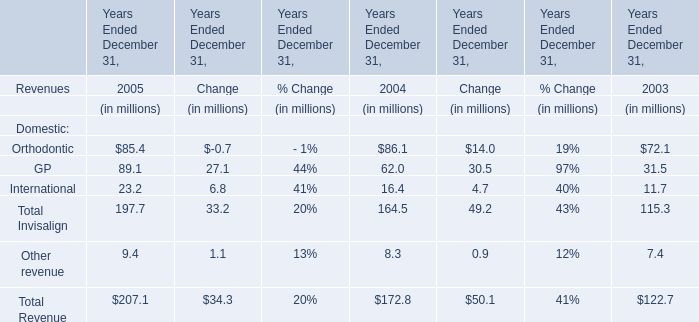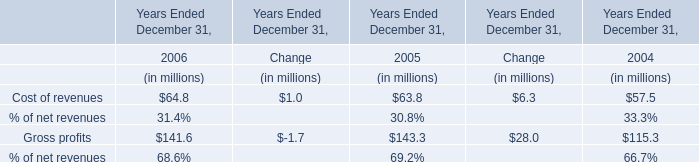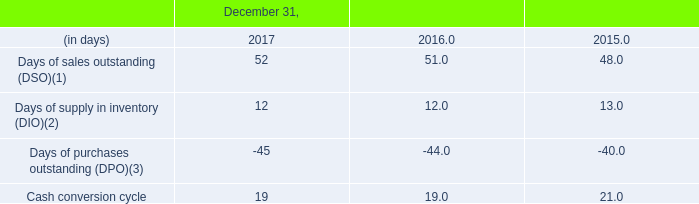what was the average capital expenditures , in millions , for 2016 and 2015? 
Computations: ((90 + 64) / 2)
Answer: 77.0. 